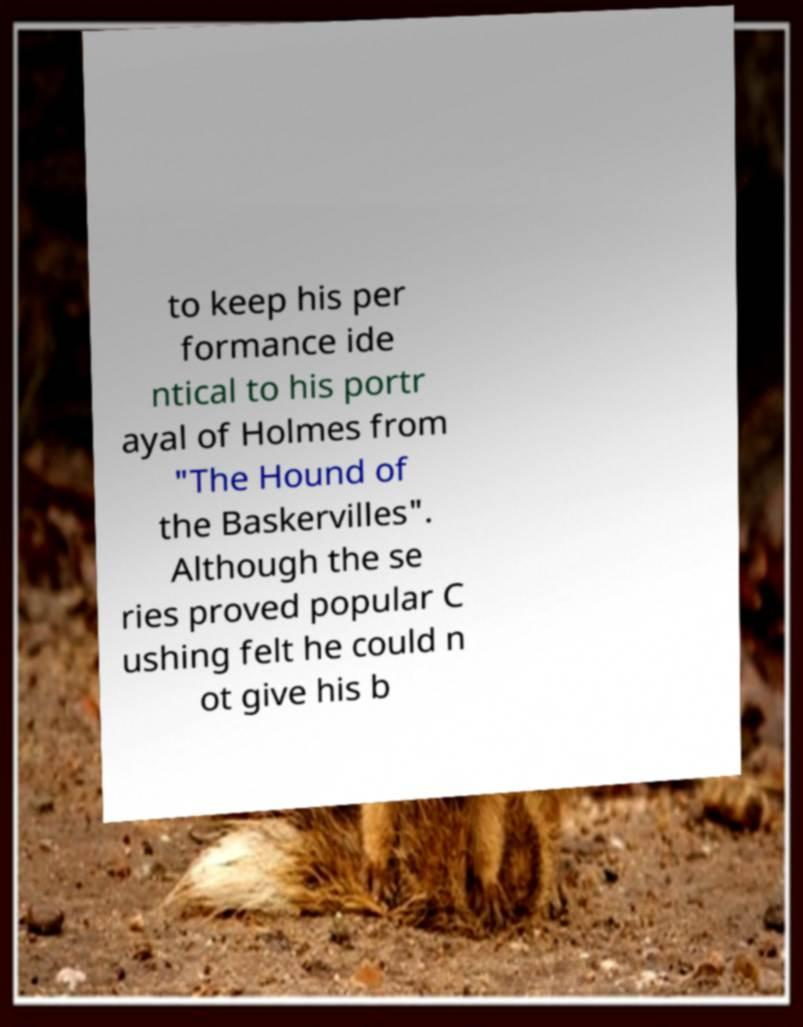What messages or text are displayed in this image? I need them in a readable, typed format. to keep his per formance ide ntical to his portr ayal of Holmes from "The Hound of the Baskervilles". Although the se ries proved popular C ushing felt he could n ot give his b 